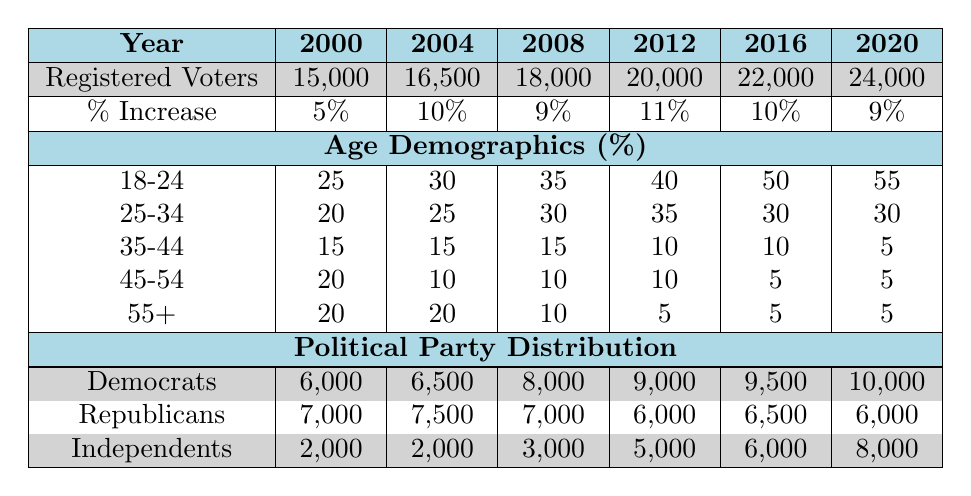What was the total number of registered voters in 2012? The table shows that in the year 2012, the number of registered voters was listed directly in the row for registered voters.
Answer: 20000 By how much did the number of registered voters increase from 2000 to 2004? The number of registered voters in 2000 was 15,000 and in 2004 it was 16,500. The difference between these two values is 16,500 - 15,000 = 1,500.
Answer: 1500 Is the percentage increase in registered voters greater in 2004 than in 2016? From the table, the percentage increase for 2004 is 10% and for 2016 it is also 10%. Therefore, the percentage increases are equal, not greater.
Answer: No What is the average percentage of voters aged 18-24 from 2000 to 2020? To find the average, add the percentages of voters aged 18-24 from each year: (25 + 30 + 35 + 40 + 50 + 55) = 235. There are 6 data points, so divide the total by 6: 235 / 6 = 39.17, rounded to two decimal places gives 39.17.
Answer: 39.17 How many Independents were registered in 2016? The table directly shows the number of Independents registered in 2016 in the political party distribution section. It states that there were 6,000 Independents.
Answer: 6000 Which age demographic saw the largest growth in percentage from 2000 to 2020? By comparing the percentages for each age group across the years 2000 (25, 20, 15, 20, 20) to 2020 (55, 30, 5, 5, 5), the age group 18-24 increased the most: 55 - 25 = 30%. This is the largest increase among the groups.
Answer: 18-24 How many registered Democrats were there in 2008? The table indicates that in 2008, the number of registered Democrats was stated in the political party distribution section, which shows 8,000 Democrats.
Answer: 8000 Is it true that the number of registered Republicans decreased from 2008 to 2012? From the table, in 2008, the registered Republicans were 7,000, and in 2012, they dropped to 6,000. Thus, this is indeed true.
Answer: Yes What was the overall increase in registered voters from 2000 to 2020? The number of registered voters in 2000 was 15,000 and in 2020 it was 24,000. The overall increase can be calculated by subtracting: 24,000 - 15,000 = 9,000.
Answer: 9000 